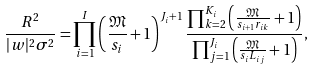Convert formula to latex. <formula><loc_0><loc_0><loc_500><loc_500>\frac { R ^ { 2 } } { | w | ^ { 2 } \sigma ^ { 2 } } = \prod _ { i = 1 } ^ { I } \left ( \frac { \mathfrak { M } } { s _ { i } } + 1 \right ) ^ { J _ { i } + 1 } \frac { \prod _ { k = 2 } ^ { K _ { i } } \left ( \frac { \mathfrak { M } } { s _ { i + 1 } r _ { i k } } + 1 \right ) } { \prod _ { j = 1 } ^ { J _ { i } } \left ( \frac { \mathfrak { M } } { s _ { i } L _ { i j } } + 1 \right ) } ,</formula> 